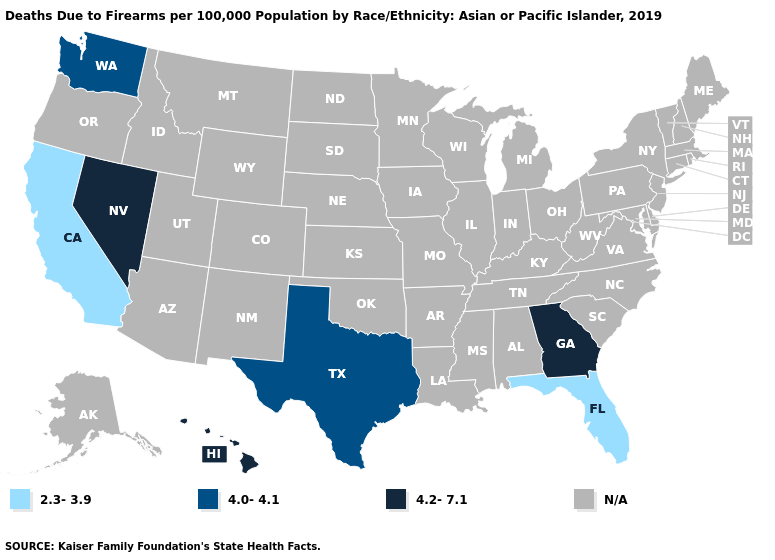Is the legend a continuous bar?
Concise answer only. No. Name the states that have a value in the range N/A?
Be succinct. Alabama, Alaska, Arizona, Arkansas, Colorado, Connecticut, Delaware, Idaho, Illinois, Indiana, Iowa, Kansas, Kentucky, Louisiana, Maine, Maryland, Massachusetts, Michigan, Minnesota, Mississippi, Missouri, Montana, Nebraska, New Hampshire, New Jersey, New Mexico, New York, North Carolina, North Dakota, Ohio, Oklahoma, Oregon, Pennsylvania, Rhode Island, South Carolina, South Dakota, Tennessee, Utah, Vermont, Virginia, West Virginia, Wisconsin, Wyoming. What is the value of Illinois?
Short answer required. N/A. Name the states that have a value in the range N/A?
Quick response, please. Alabama, Alaska, Arizona, Arkansas, Colorado, Connecticut, Delaware, Idaho, Illinois, Indiana, Iowa, Kansas, Kentucky, Louisiana, Maine, Maryland, Massachusetts, Michigan, Minnesota, Mississippi, Missouri, Montana, Nebraska, New Hampshire, New Jersey, New Mexico, New York, North Carolina, North Dakota, Ohio, Oklahoma, Oregon, Pennsylvania, Rhode Island, South Carolina, South Dakota, Tennessee, Utah, Vermont, Virginia, West Virginia, Wisconsin, Wyoming. Name the states that have a value in the range 4.0-4.1?
Quick response, please. Texas, Washington. Name the states that have a value in the range N/A?
Quick response, please. Alabama, Alaska, Arizona, Arkansas, Colorado, Connecticut, Delaware, Idaho, Illinois, Indiana, Iowa, Kansas, Kentucky, Louisiana, Maine, Maryland, Massachusetts, Michigan, Minnesota, Mississippi, Missouri, Montana, Nebraska, New Hampshire, New Jersey, New Mexico, New York, North Carolina, North Dakota, Ohio, Oklahoma, Oregon, Pennsylvania, Rhode Island, South Carolina, South Dakota, Tennessee, Utah, Vermont, Virginia, West Virginia, Wisconsin, Wyoming. Name the states that have a value in the range 4.2-7.1?
Quick response, please. Georgia, Hawaii, Nevada. Name the states that have a value in the range N/A?
Write a very short answer. Alabama, Alaska, Arizona, Arkansas, Colorado, Connecticut, Delaware, Idaho, Illinois, Indiana, Iowa, Kansas, Kentucky, Louisiana, Maine, Maryland, Massachusetts, Michigan, Minnesota, Mississippi, Missouri, Montana, Nebraska, New Hampshire, New Jersey, New Mexico, New York, North Carolina, North Dakota, Ohio, Oklahoma, Oregon, Pennsylvania, Rhode Island, South Carolina, South Dakota, Tennessee, Utah, Vermont, Virginia, West Virginia, Wisconsin, Wyoming. What is the value of Michigan?
Write a very short answer. N/A. 